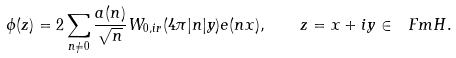<formula> <loc_0><loc_0><loc_500><loc_500>\phi ( z ) = 2 \sum _ { n \not = 0 } \frac { a ( n ) } { \sqrt { n } } W _ { 0 , i r } ( 4 \pi | n | y ) e ( n x ) , \quad z = x + i y \in \ F m H .</formula> 